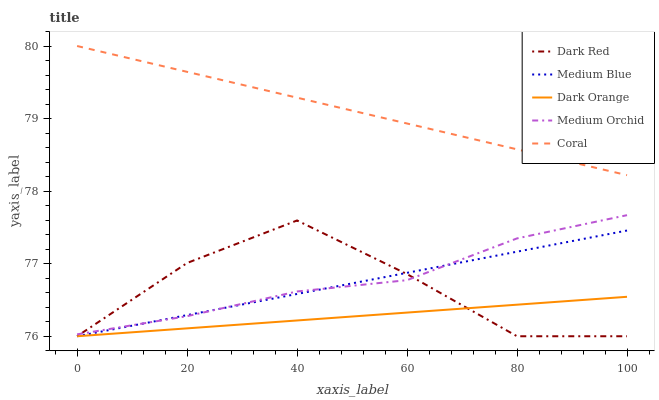Does Dark Orange have the minimum area under the curve?
Answer yes or no. Yes. Does Coral have the maximum area under the curve?
Answer yes or no. Yes. Does Medium Orchid have the minimum area under the curve?
Answer yes or no. No. Does Medium Orchid have the maximum area under the curve?
Answer yes or no. No. Is Dark Orange the smoothest?
Answer yes or no. Yes. Is Dark Red the roughest?
Answer yes or no. Yes. Is Coral the smoothest?
Answer yes or no. No. Is Coral the roughest?
Answer yes or no. No. Does Dark Red have the lowest value?
Answer yes or no. Yes. Does Medium Orchid have the lowest value?
Answer yes or no. No. Does Coral have the highest value?
Answer yes or no. Yes. Does Medium Orchid have the highest value?
Answer yes or no. No. Is Medium Blue less than Coral?
Answer yes or no. Yes. Is Coral greater than Dark Red?
Answer yes or no. Yes. Does Dark Red intersect Medium Blue?
Answer yes or no. Yes. Is Dark Red less than Medium Blue?
Answer yes or no. No. Is Dark Red greater than Medium Blue?
Answer yes or no. No. Does Medium Blue intersect Coral?
Answer yes or no. No. 